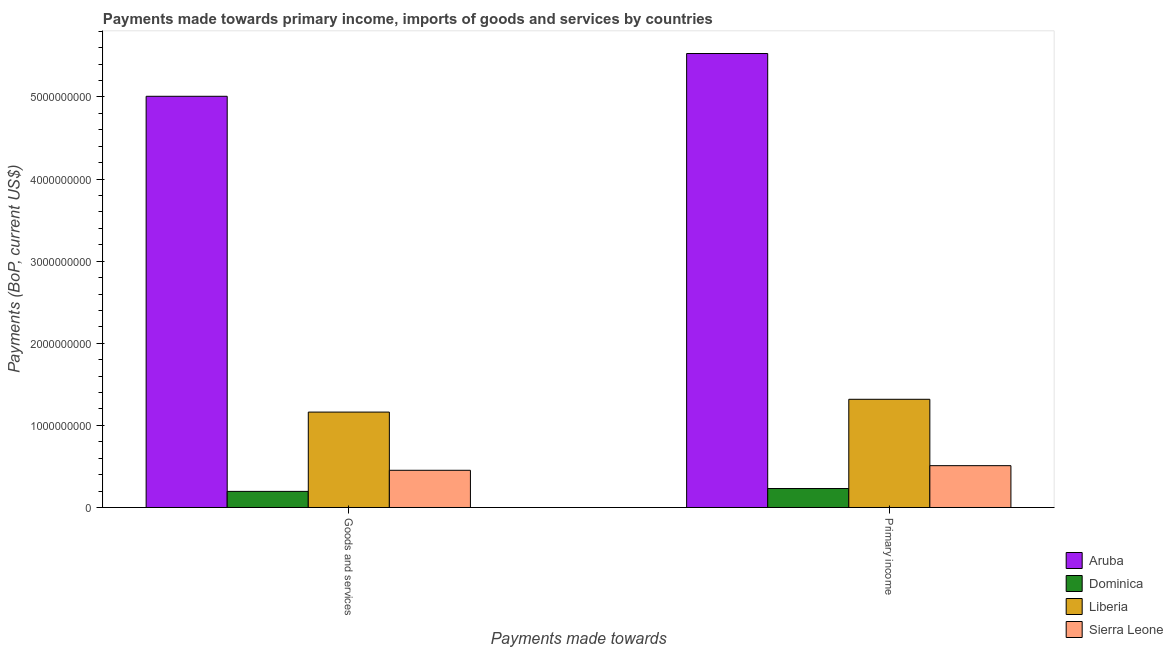How many groups of bars are there?
Your answer should be compact. 2. Are the number of bars per tick equal to the number of legend labels?
Keep it short and to the point. Yes. Are the number of bars on each tick of the X-axis equal?
Your response must be concise. Yes. How many bars are there on the 2nd tick from the left?
Make the answer very short. 4. How many bars are there on the 2nd tick from the right?
Offer a terse response. 4. What is the label of the 2nd group of bars from the left?
Your response must be concise. Primary income. What is the payments made towards goods and services in Sierra Leone?
Ensure brevity in your answer.  4.53e+08. Across all countries, what is the maximum payments made towards primary income?
Ensure brevity in your answer.  5.53e+09. Across all countries, what is the minimum payments made towards primary income?
Make the answer very short. 2.31e+08. In which country was the payments made towards primary income maximum?
Ensure brevity in your answer.  Aruba. In which country was the payments made towards goods and services minimum?
Provide a short and direct response. Dominica. What is the total payments made towards primary income in the graph?
Offer a very short reply. 7.59e+09. What is the difference between the payments made towards goods and services in Aruba and that in Dominica?
Offer a very short reply. 4.81e+09. What is the difference between the payments made towards goods and services in Liberia and the payments made towards primary income in Aruba?
Your response must be concise. -4.37e+09. What is the average payments made towards goods and services per country?
Provide a succinct answer. 1.70e+09. What is the difference between the payments made towards primary income and payments made towards goods and services in Dominica?
Ensure brevity in your answer.  3.49e+07. In how many countries, is the payments made towards goods and services greater than 4800000000 US$?
Make the answer very short. 1. What is the ratio of the payments made towards primary income in Sierra Leone to that in Liberia?
Your answer should be very brief. 0.39. Is the payments made towards goods and services in Liberia less than that in Dominica?
Keep it short and to the point. No. What does the 2nd bar from the left in Goods and services represents?
Your answer should be compact. Dominica. What does the 4th bar from the right in Goods and services represents?
Your answer should be compact. Aruba. Are all the bars in the graph horizontal?
Your answer should be compact. No. What is the difference between two consecutive major ticks on the Y-axis?
Your answer should be compact. 1.00e+09. Does the graph contain any zero values?
Provide a succinct answer. No. Does the graph contain grids?
Your answer should be very brief. No. How many legend labels are there?
Your answer should be very brief. 4. How are the legend labels stacked?
Give a very brief answer. Vertical. What is the title of the graph?
Provide a short and direct response. Payments made towards primary income, imports of goods and services by countries. Does "Costa Rica" appear as one of the legend labels in the graph?
Keep it short and to the point. No. What is the label or title of the X-axis?
Keep it short and to the point. Payments made towards. What is the label or title of the Y-axis?
Ensure brevity in your answer.  Payments (BoP, current US$). What is the Payments (BoP, current US$) of Aruba in Goods and services?
Ensure brevity in your answer.  5.01e+09. What is the Payments (BoP, current US$) in Dominica in Goods and services?
Offer a very short reply. 1.96e+08. What is the Payments (BoP, current US$) of Liberia in Goods and services?
Give a very brief answer. 1.16e+09. What is the Payments (BoP, current US$) in Sierra Leone in Goods and services?
Make the answer very short. 4.53e+08. What is the Payments (BoP, current US$) in Aruba in Primary income?
Keep it short and to the point. 5.53e+09. What is the Payments (BoP, current US$) in Dominica in Primary income?
Provide a succinct answer. 2.31e+08. What is the Payments (BoP, current US$) in Liberia in Primary income?
Ensure brevity in your answer.  1.32e+09. What is the Payments (BoP, current US$) in Sierra Leone in Primary income?
Offer a very short reply. 5.09e+08. Across all Payments made towards, what is the maximum Payments (BoP, current US$) of Aruba?
Offer a very short reply. 5.53e+09. Across all Payments made towards, what is the maximum Payments (BoP, current US$) in Dominica?
Your answer should be very brief. 2.31e+08. Across all Payments made towards, what is the maximum Payments (BoP, current US$) of Liberia?
Your answer should be compact. 1.32e+09. Across all Payments made towards, what is the maximum Payments (BoP, current US$) of Sierra Leone?
Give a very brief answer. 5.09e+08. Across all Payments made towards, what is the minimum Payments (BoP, current US$) of Aruba?
Offer a very short reply. 5.01e+09. Across all Payments made towards, what is the minimum Payments (BoP, current US$) in Dominica?
Your response must be concise. 1.96e+08. Across all Payments made towards, what is the minimum Payments (BoP, current US$) of Liberia?
Give a very brief answer. 1.16e+09. Across all Payments made towards, what is the minimum Payments (BoP, current US$) of Sierra Leone?
Your answer should be compact. 4.53e+08. What is the total Payments (BoP, current US$) of Aruba in the graph?
Ensure brevity in your answer.  1.05e+1. What is the total Payments (BoP, current US$) in Dominica in the graph?
Your answer should be compact. 4.27e+08. What is the total Payments (BoP, current US$) of Liberia in the graph?
Make the answer very short. 2.48e+09. What is the total Payments (BoP, current US$) of Sierra Leone in the graph?
Keep it short and to the point. 9.62e+08. What is the difference between the Payments (BoP, current US$) of Aruba in Goods and services and that in Primary income?
Your answer should be compact. -5.21e+08. What is the difference between the Payments (BoP, current US$) of Dominica in Goods and services and that in Primary income?
Give a very brief answer. -3.49e+07. What is the difference between the Payments (BoP, current US$) in Liberia in Goods and services and that in Primary income?
Ensure brevity in your answer.  -1.56e+08. What is the difference between the Payments (BoP, current US$) in Sierra Leone in Goods and services and that in Primary income?
Provide a succinct answer. -5.63e+07. What is the difference between the Payments (BoP, current US$) of Aruba in Goods and services and the Payments (BoP, current US$) of Dominica in Primary income?
Your response must be concise. 4.78e+09. What is the difference between the Payments (BoP, current US$) in Aruba in Goods and services and the Payments (BoP, current US$) in Liberia in Primary income?
Your response must be concise. 3.69e+09. What is the difference between the Payments (BoP, current US$) of Aruba in Goods and services and the Payments (BoP, current US$) of Sierra Leone in Primary income?
Give a very brief answer. 4.50e+09. What is the difference between the Payments (BoP, current US$) in Dominica in Goods and services and the Payments (BoP, current US$) in Liberia in Primary income?
Provide a succinct answer. -1.12e+09. What is the difference between the Payments (BoP, current US$) of Dominica in Goods and services and the Payments (BoP, current US$) of Sierra Leone in Primary income?
Offer a terse response. -3.13e+08. What is the difference between the Payments (BoP, current US$) of Liberia in Goods and services and the Payments (BoP, current US$) of Sierra Leone in Primary income?
Your answer should be very brief. 6.53e+08. What is the average Payments (BoP, current US$) in Aruba per Payments made towards?
Provide a succinct answer. 5.27e+09. What is the average Payments (BoP, current US$) of Dominica per Payments made towards?
Give a very brief answer. 2.14e+08. What is the average Payments (BoP, current US$) of Liberia per Payments made towards?
Keep it short and to the point. 1.24e+09. What is the average Payments (BoP, current US$) in Sierra Leone per Payments made towards?
Ensure brevity in your answer.  4.81e+08. What is the difference between the Payments (BoP, current US$) in Aruba and Payments (BoP, current US$) in Dominica in Goods and services?
Offer a terse response. 4.81e+09. What is the difference between the Payments (BoP, current US$) in Aruba and Payments (BoP, current US$) in Liberia in Goods and services?
Give a very brief answer. 3.85e+09. What is the difference between the Payments (BoP, current US$) in Aruba and Payments (BoP, current US$) in Sierra Leone in Goods and services?
Offer a terse response. 4.55e+09. What is the difference between the Payments (BoP, current US$) of Dominica and Payments (BoP, current US$) of Liberia in Goods and services?
Provide a succinct answer. -9.66e+08. What is the difference between the Payments (BoP, current US$) of Dominica and Payments (BoP, current US$) of Sierra Leone in Goods and services?
Ensure brevity in your answer.  -2.57e+08. What is the difference between the Payments (BoP, current US$) in Liberia and Payments (BoP, current US$) in Sierra Leone in Goods and services?
Give a very brief answer. 7.09e+08. What is the difference between the Payments (BoP, current US$) in Aruba and Payments (BoP, current US$) in Dominica in Primary income?
Give a very brief answer. 5.30e+09. What is the difference between the Payments (BoP, current US$) in Aruba and Payments (BoP, current US$) in Liberia in Primary income?
Make the answer very short. 4.21e+09. What is the difference between the Payments (BoP, current US$) of Aruba and Payments (BoP, current US$) of Sierra Leone in Primary income?
Provide a short and direct response. 5.02e+09. What is the difference between the Payments (BoP, current US$) in Dominica and Payments (BoP, current US$) in Liberia in Primary income?
Provide a short and direct response. -1.09e+09. What is the difference between the Payments (BoP, current US$) of Dominica and Payments (BoP, current US$) of Sierra Leone in Primary income?
Give a very brief answer. -2.78e+08. What is the difference between the Payments (BoP, current US$) in Liberia and Payments (BoP, current US$) in Sierra Leone in Primary income?
Offer a very short reply. 8.08e+08. What is the ratio of the Payments (BoP, current US$) of Aruba in Goods and services to that in Primary income?
Keep it short and to the point. 0.91. What is the ratio of the Payments (BoP, current US$) in Dominica in Goods and services to that in Primary income?
Make the answer very short. 0.85. What is the ratio of the Payments (BoP, current US$) in Liberia in Goods and services to that in Primary income?
Make the answer very short. 0.88. What is the ratio of the Payments (BoP, current US$) of Sierra Leone in Goods and services to that in Primary income?
Offer a very short reply. 0.89. What is the difference between the highest and the second highest Payments (BoP, current US$) of Aruba?
Your answer should be compact. 5.21e+08. What is the difference between the highest and the second highest Payments (BoP, current US$) in Dominica?
Offer a terse response. 3.49e+07. What is the difference between the highest and the second highest Payments (BoP, current US$) of Liberia?
Your answer should be very brief. 1.56e+08. What is the difference between the highest and the second highest Payments (BoP, current US$) of Sierra Leone?
Make the answer very short. 5.63e+07. What is the difference between the highest and the lowest Payments (BoP, current US$) in Aruba?
Keep it short and to the point. 5.21e+08. What is the difference between the highest and the lowest Payments (BoP, current US$) of Dominica?
Offer a very short reply. 3.49e+07. What is the difference between the highest and the lowest Payments (BoP, current US$) in Liberia?
Make the answer very short. 1.56e+08. What is the difference between the highest and the lowest Payments (BoP, current US$) in Sierra Leone?
Keep it short and to the point. 5.63e+07. 